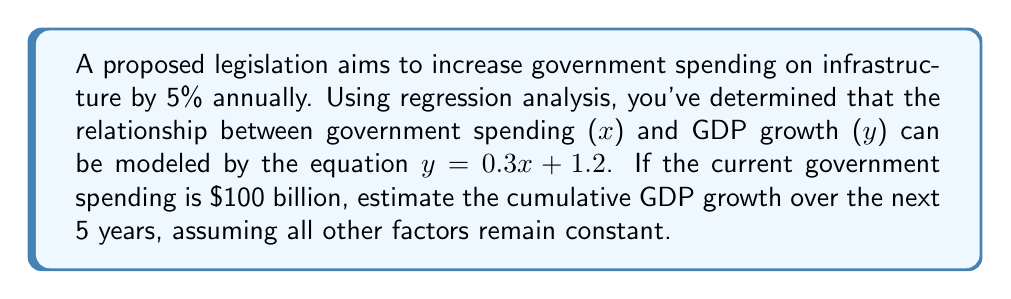Solve this math problem. 1) First, we need to calculate the government spending for each year:
   Year 0 (current): $100 billion
   Year 1: $100 * 1.05 = $105 billion
   Year 2: $105 * 1.05 = $110.25 billion
   Year 3: $110.25 * 1.05 = $115.7625 billion
   Year 4: $115.7625 * 1.05 = $121.550625 billion
   Year 5: $121.550625 * 1.05 = $127.62815625 billion

2) Now, we use the regression equation $y = 0.3x + 1.2$ to calculate GDP growth for each year:
   Year 1: $y = 0.3(105) + 1.2 = 32.7\%$
   Year 2: $y = 0.3(110.25) + 1.2 = 34.275\%$
   Year 3: $y = 0.3(115.7625) + 1.2 = 35.92875\%$
   Year 4: $y = 0.3(121.550625) + 1.2 = 37.6651875\%$
   Year 5: $y = 0.3(127.62815625) + 1.2 = 39.48844688\%$

3) To find the cumulative GDP growth, we sum these percentages:
   $$32.7 + 34.275 + 35.92875 + 37.6651875 + 39.48844688 = 180.05738438\%$$

Therefore, the estimated cumulative GDP growth over the next 5 years is approximately 180.06%.
Answer: 180.06% 